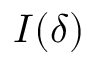<formula> <loc_0><loc_0><loc_500><loc_500>I ( \delta )</formula> 